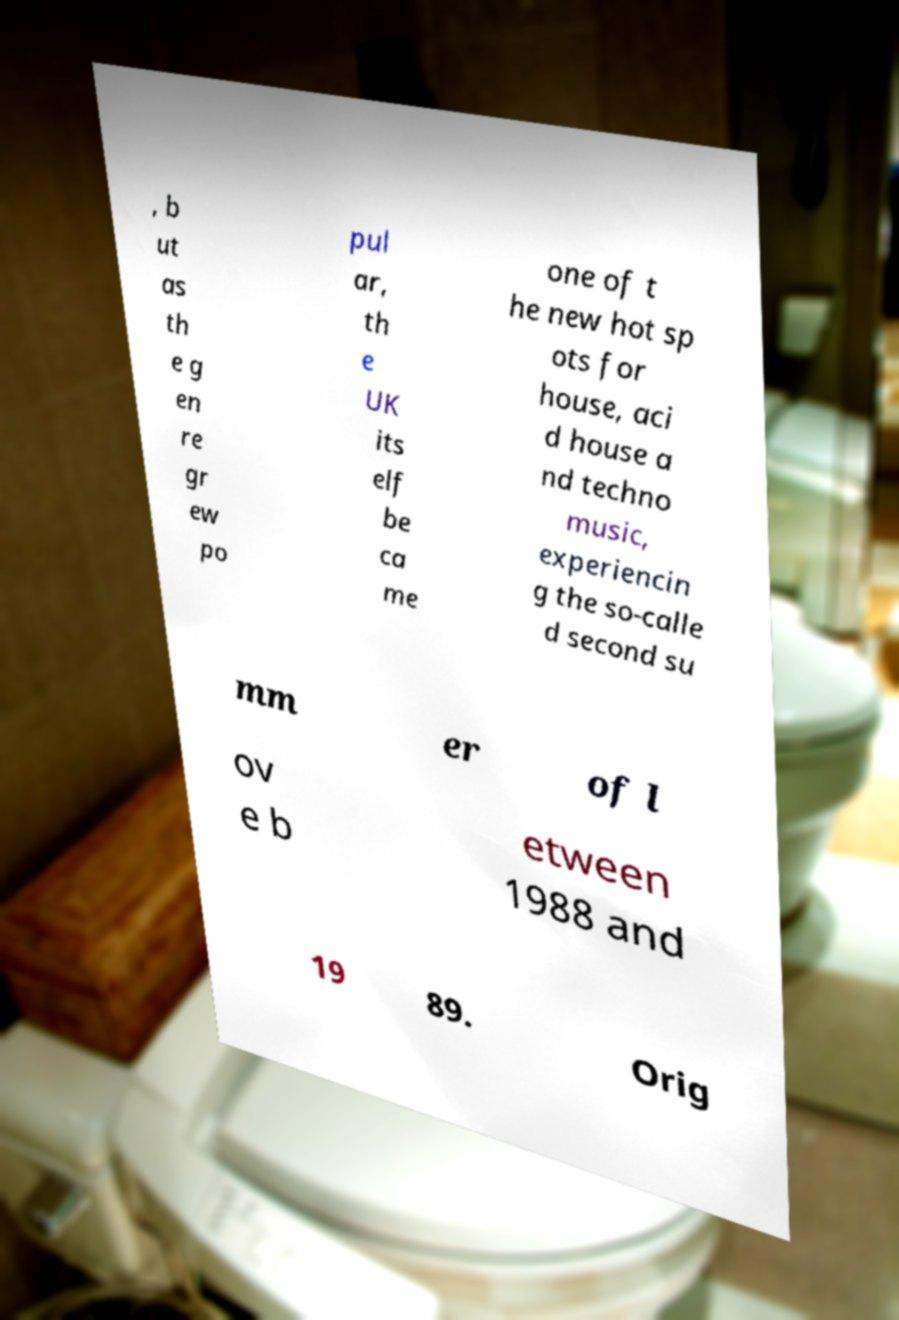Could you extract and type out the text from this image? , b ut as th e g en re gr ew po pul ar, th e UK its elf be ca me one of t he new hot sp ots for house, aci d house a nd techno music, experiencin g the so-calle d second su mm er of l ov e b etween 1988 and 19 89. Orig 